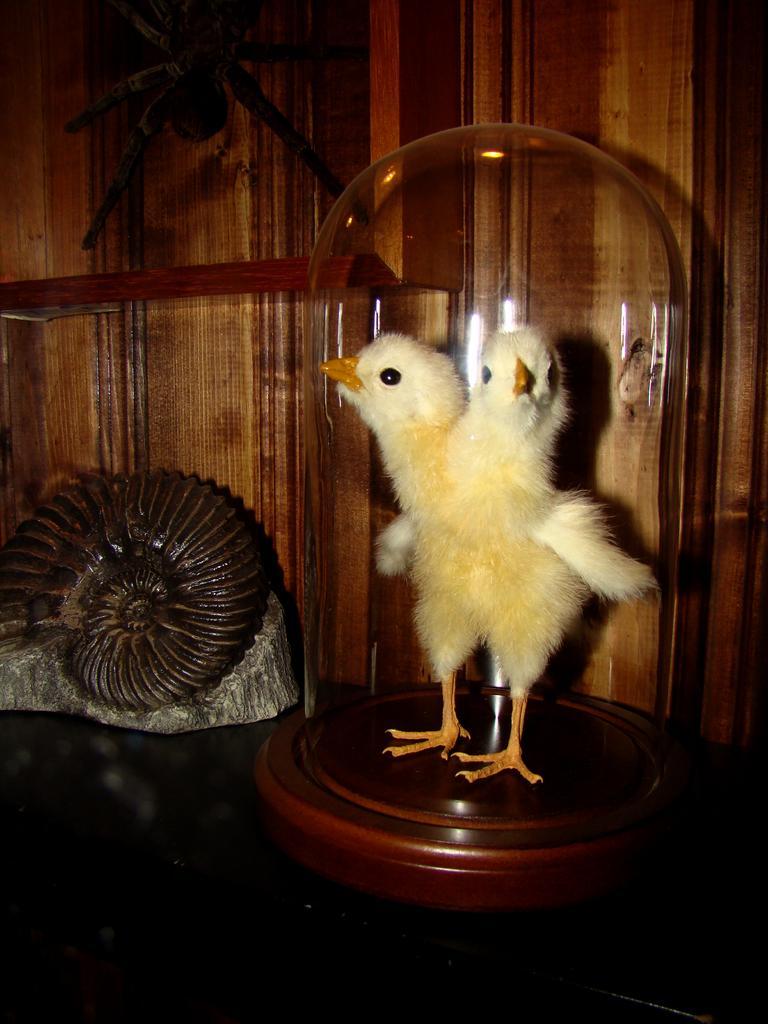Describe this image in one or two sentences. In the center of the image there is a depiction of a chick. In the background of the image there is a wooden wall. There is a object to the left side of the image. 